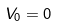Convert formula to latex. <formula><loc_0><loc_0><loc_500><loc_500>V _ { 0 } = 0</formula> 